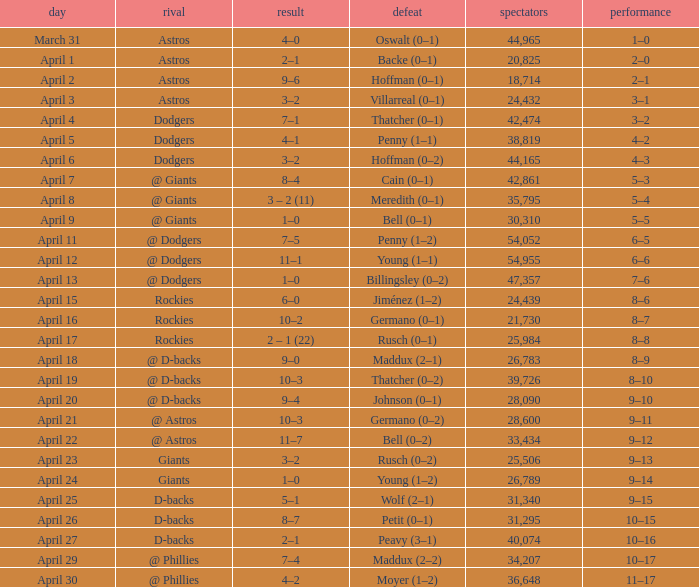What was the score on April 21? 10–3. 